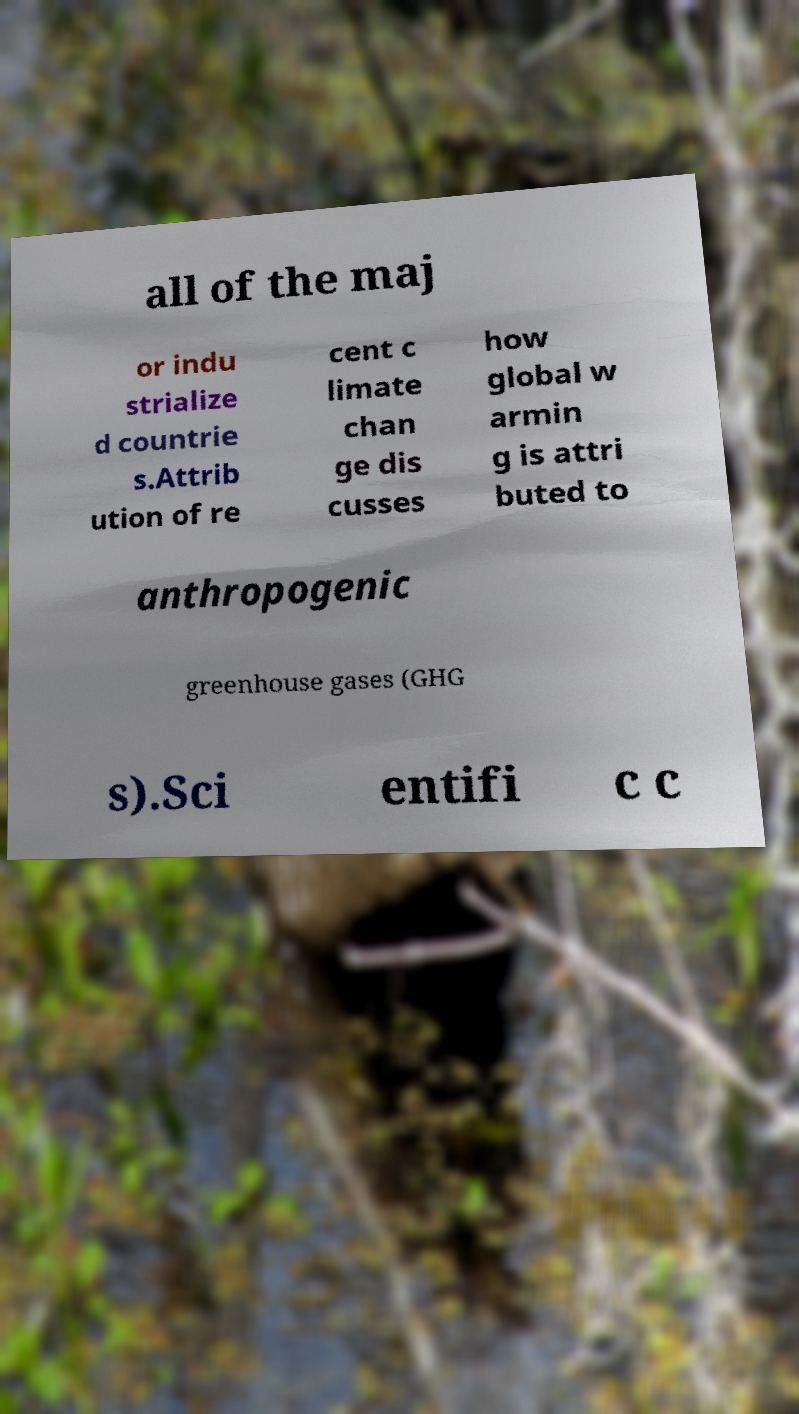Can you accurately transcribe the text from the provided image for me? all of the maj or indu strialize d countrie s.Attrib ution of re cent c limate chan ge dis cusses how global w armin g is attri buted to anthropogenic greenhouse gases (GHG s).Sci entifi c c 